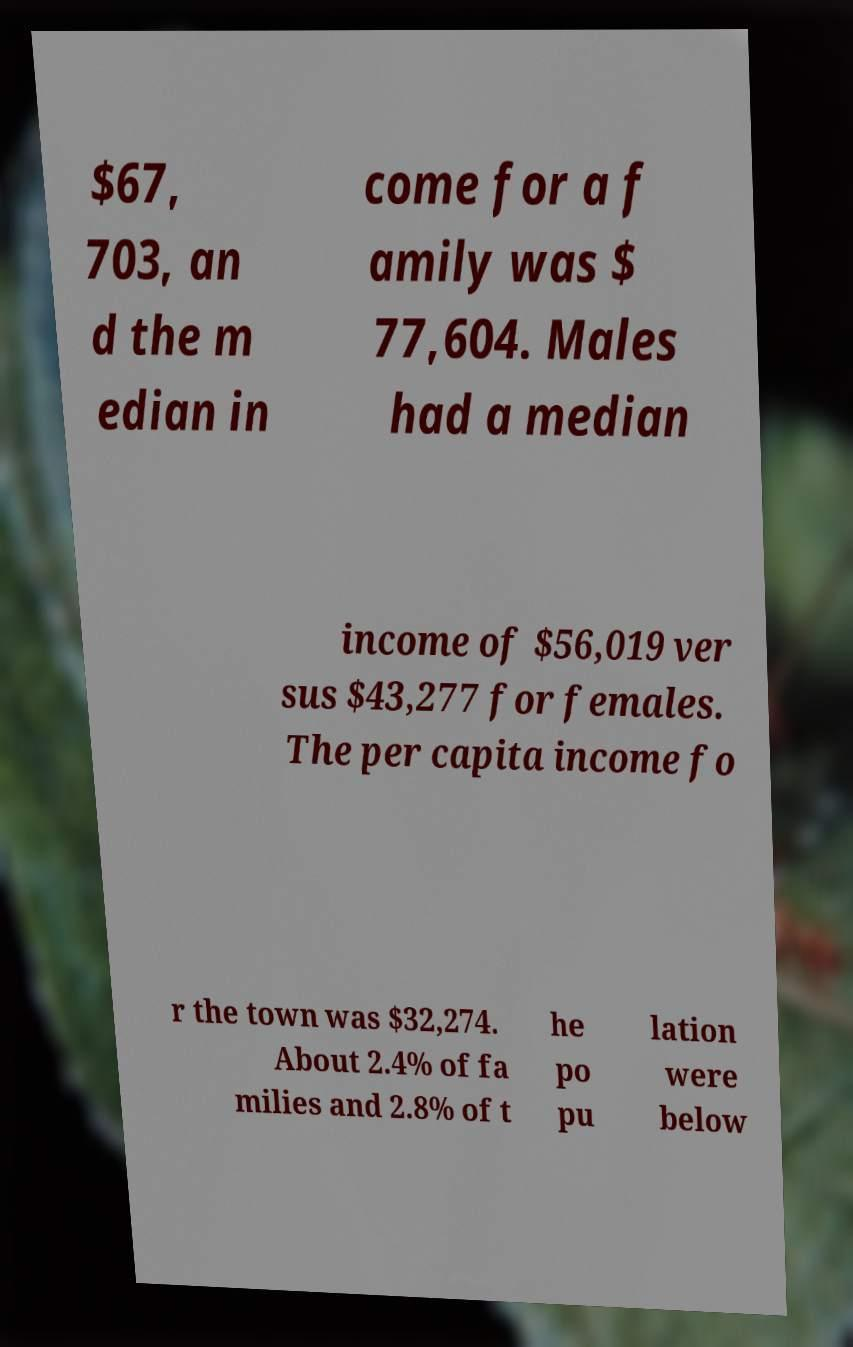For documentation purposes, I need the text within this image transcribed. Could you provide that? $67, 703, an d the m edian in come for a f amily was $ 77,604. Males had a median income of $56,019 ver sus $43,277 for females. The per capita income fo r the town was $32,274. About 2.4% of fa milies and 2.8% of t he po pu lation were below 